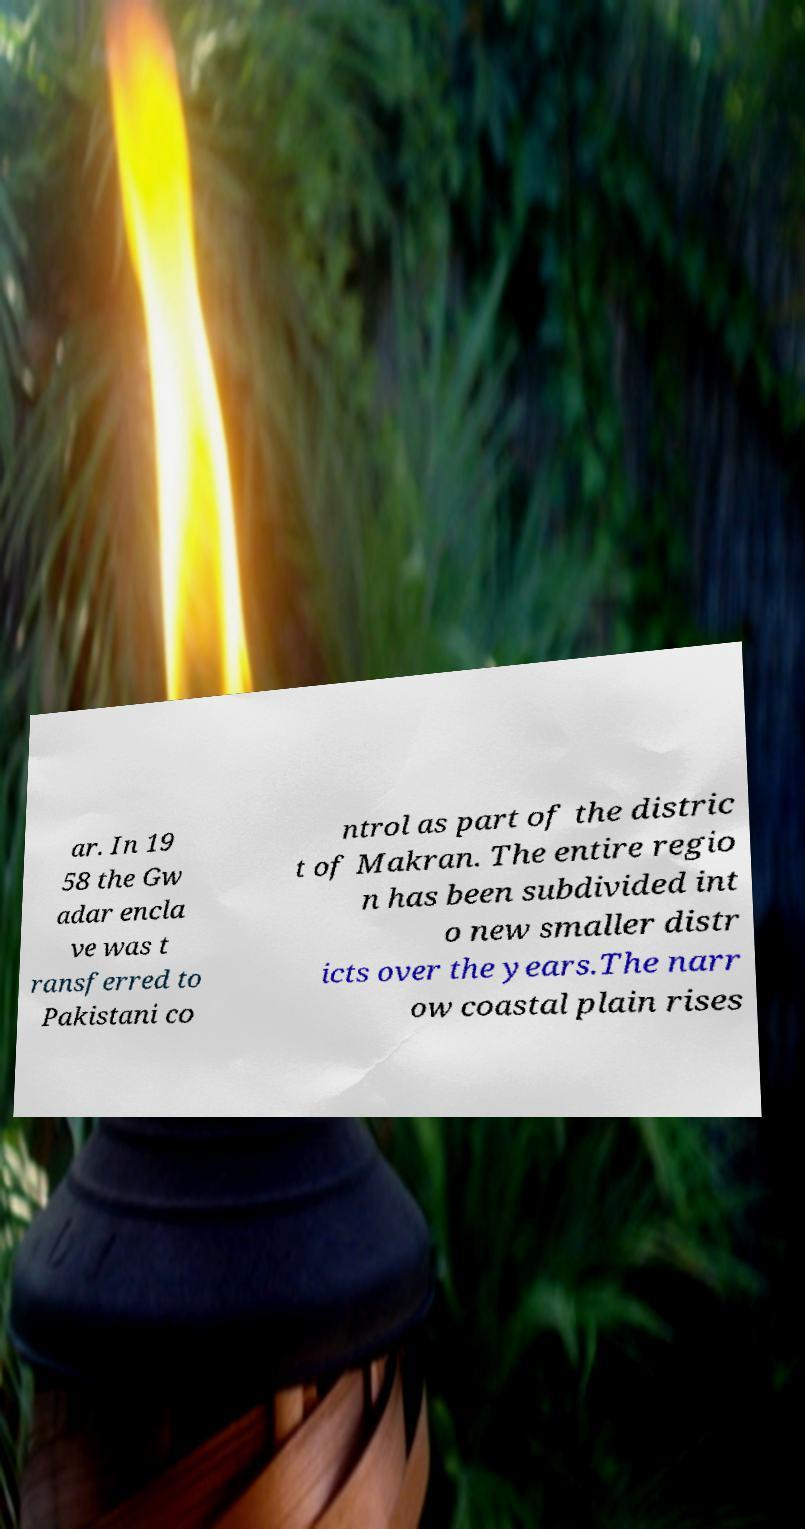Could you extract and type out the text from this image? ar. In 19 58 the Gw adar encla ve was t ransferred to Pakistani co ntrol as part of the distric t of Makran. The entire regio n has been subdivided int o new smaller distr icts over the years.The narr ow coastal plain rises 